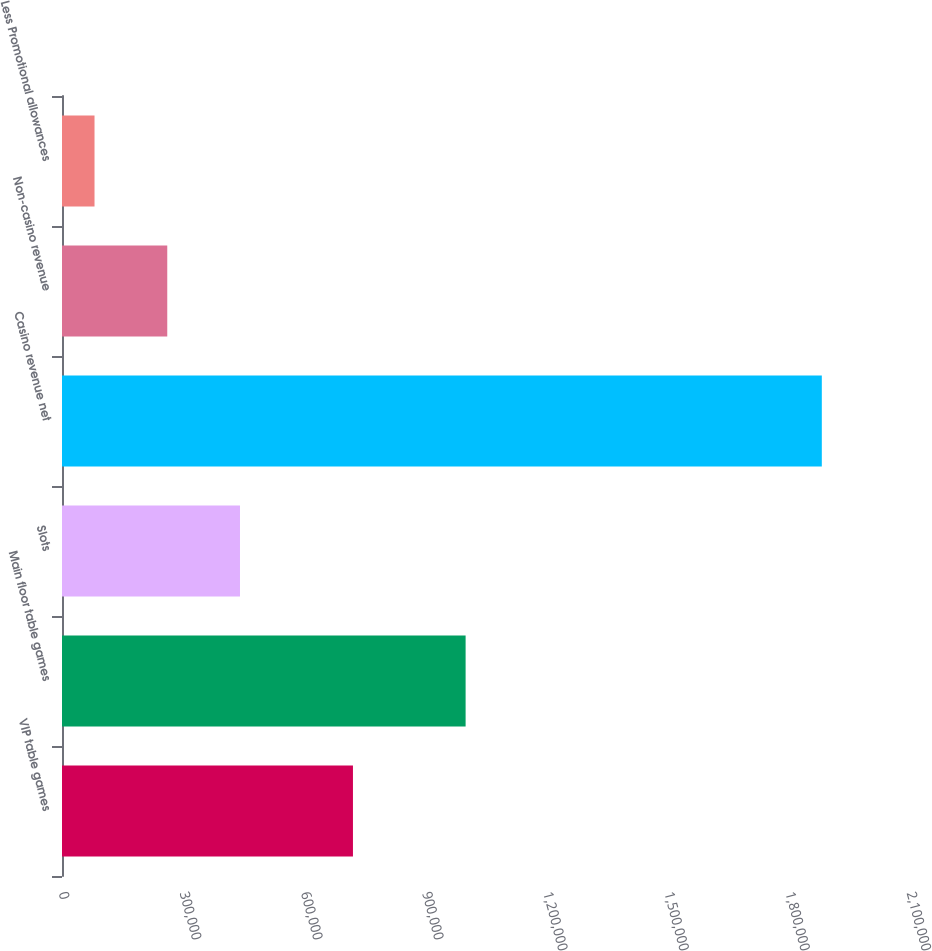Convert chart. <chart><loc_0><loc_0><loc_500><loc_500><bar_chart><fcel>VIP table games<fcel>Main floor table games<fcel>Slots<fcel>Casino revenue net<fcel>Non-casino revenue<fcel>Less Promotional allowances<nl><fcel>720522<fcel>999506<fcel>440760<fcel>1.88161e+06<fcel>260653<fcel>80546<nl></chart> 